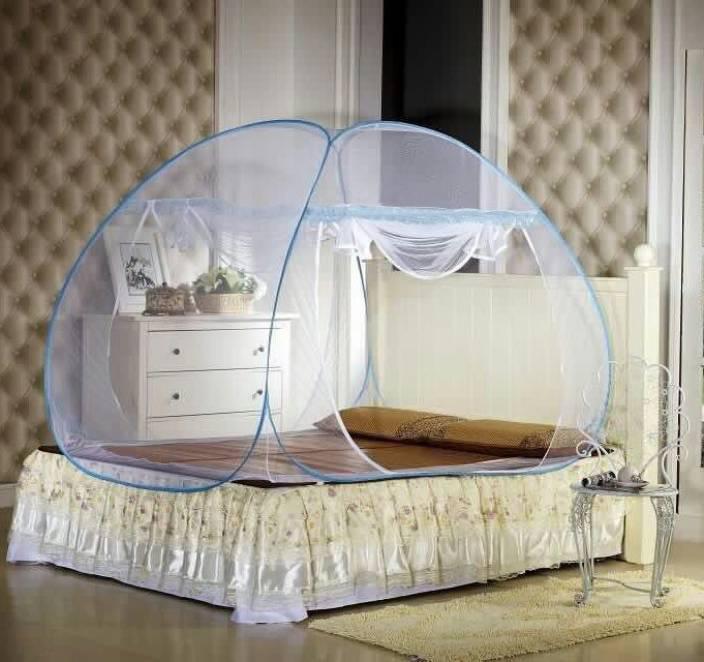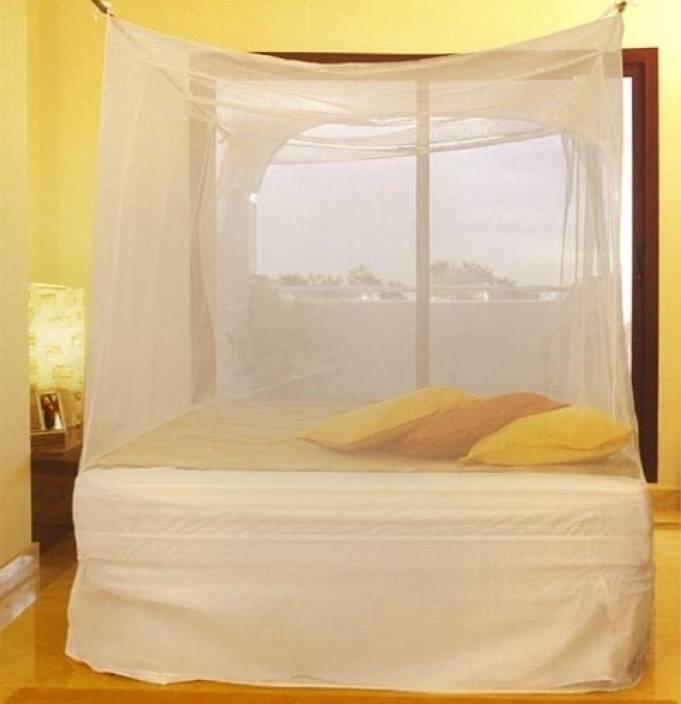The first image is the image on the left, the second image is the image on the right. Evaluate the accuracy of this statement regarding the images: "There is a square canopy over a mattress on the floor". Is it true? Answer yes or no. No. The first image is the image on the left, the second image is the image on the right. Given the left and right images, does the statement "At least one of the nets is blue." hold true? Answer yes or no. Yes. 